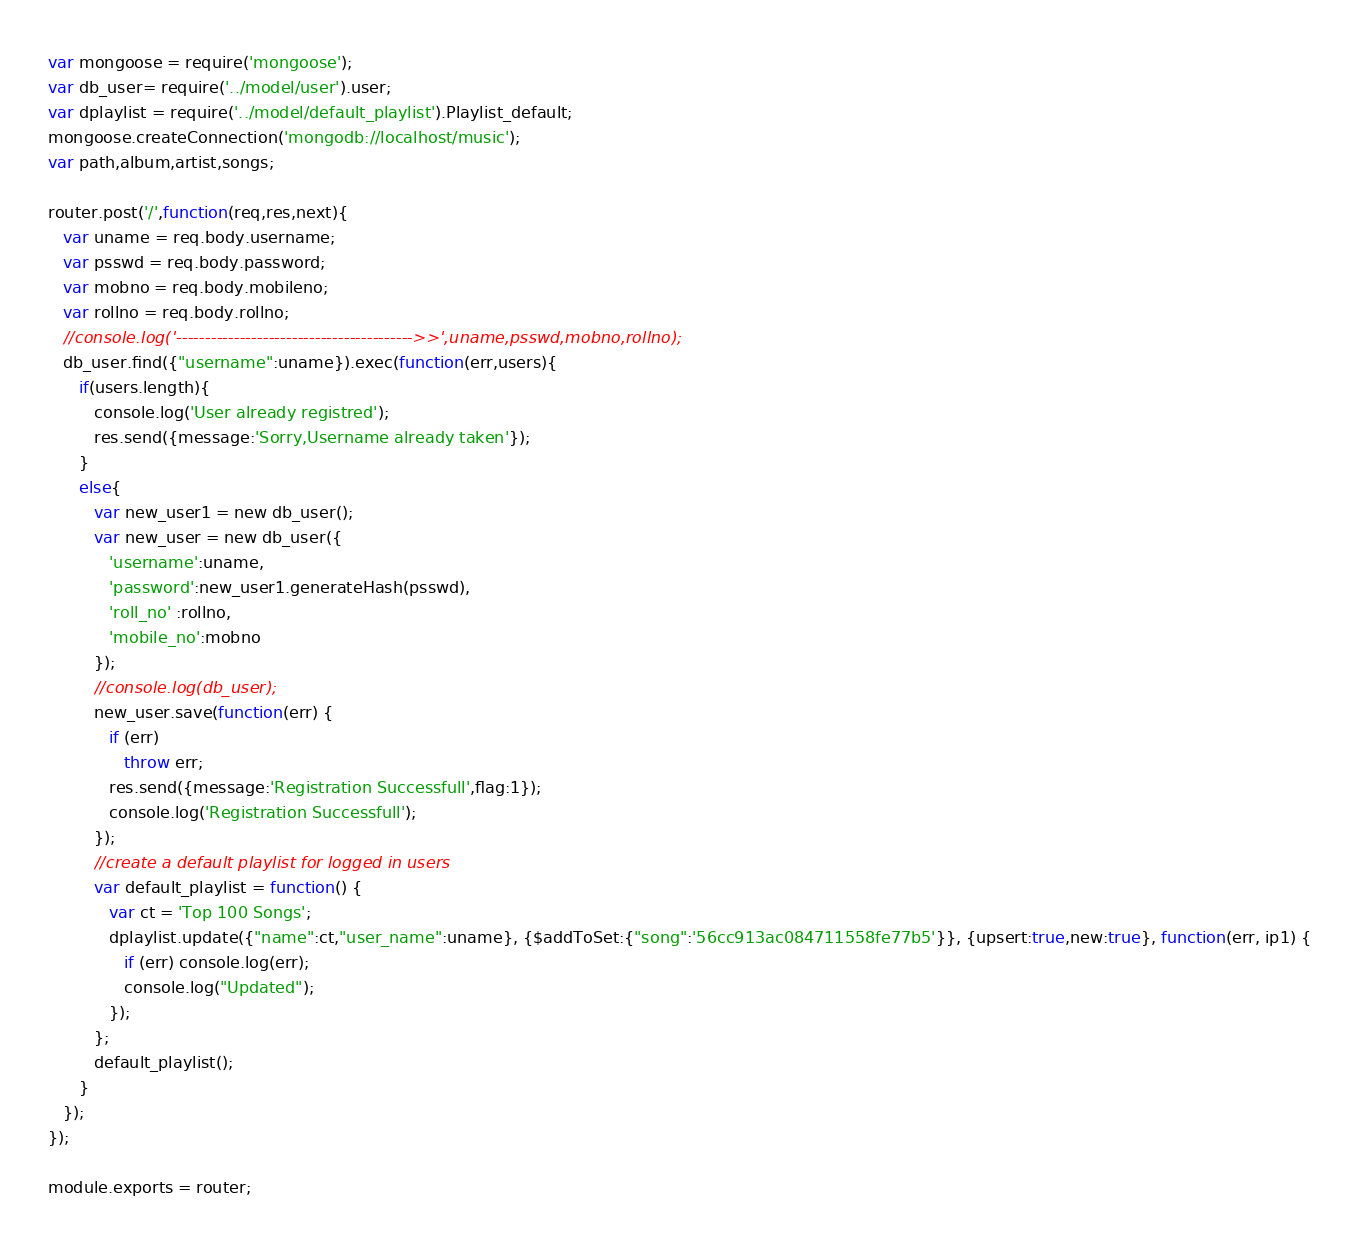Convert code to text. <code><loc_0><loc_0><loc_500><loc_500><_JavaScript_>var mongoose = require('mongoose');
var db_user= require('../model/user').user;
var dplaylist = require('../model/default_playlist').Playlist_default;
mongoose.createConnection('mongodb://localhost/music');
var path,album,artist,songs;

router.post('/',function(req,res,next){
   var uname = req.body.username;
   var psswd = req.body.password;
   var mobno = req.body.mobileno;
   var rollno = req.body.rollno;
   //console.log('----------------------------------------->>',uname,psswd,mobno,rollno);
   db_user.find({"username":uname}).exec(function(err,users){
      if(users.length){
         console.log('User already registred');
         res.send({message:'Sorry,Username already taken'});
      }
      else{
         var new_user1 = new db_user();
         var new_user = new db_user({
            'username':uname,
            'password':new_user1.generateHash(psswd),
            'roll_no' :rollno,
            'mobile_no':mobno
         });
         //console.log(db_user);
         new_user.save(function(err) {
            if (err)
               throw err;
            res.send({message:'Registration Successfull',flag:1});
            console.log('Registration Successfull');
         });
         //create a default playlist for logged in users
         var default_playlist = function() {
            var ct = 'Top 100 Songs';
            dplaylist.update({"name":ct,"user_name":uname}, {$addToSet:{"song":'56cc913ac084711558fe77b5'}}, {upsert:true,new:true}, function(err, ip1) {
               if (err) console.log(err);
               console.log("Updated");
            });
         };
         default_playlist();
      }
   });
});

module.exports = router;
</code> 